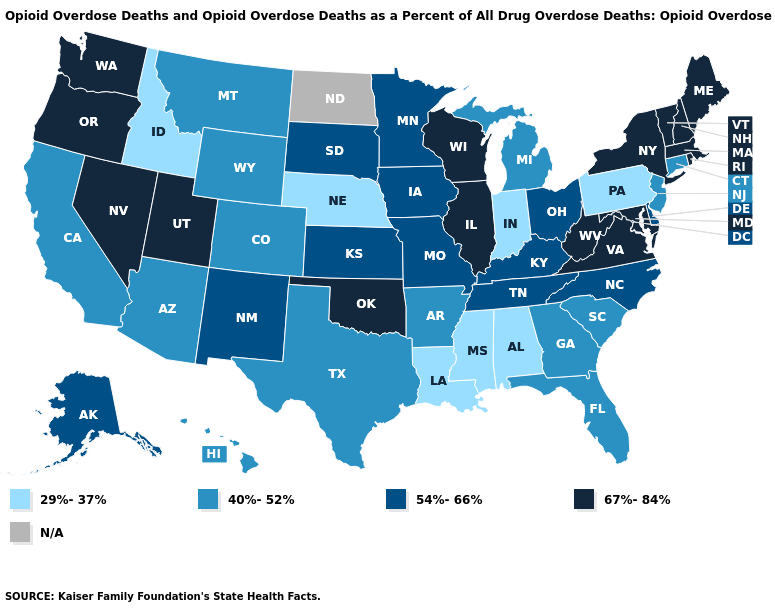How many symbols are there in the legend?
Be succinct. 5. What is the highest value in the Northeast ?
Quick response, please. 67%-84%. What is the highest value in the USA?
Concise answer only. 67%-84%. Is the legend a continuous bar?
Quick response, please. No. What is the value of Colorado?
Answer briefly. 40%-52%. Does the map have missing data?
Keep it brief. Yes. How many symbols are there in the legend?
Answer briefly. 5. What is the value of Maine?
Concise answer only. 67%-84%. Name the states that have a value in the range 40%-52%?
Answer briefly. Arizona, Arkansas, California, Colorado, Connecticut, Florida, Georgia, Hawaii, Michigan, Montana, New Jersey, South Carolina, Texas, Wyoming. What is the value of Tennessee?
Short answer required. 54%-66%. Among the states that border North Dakota , which have the lowest value?
Give a very brief answer. Montana. What is the highest value in the MidWest ?
Be succinct. 67%-84%. Does the map have missing data?
Keep it brief. Yes. What is the value of Michigan?
Be succinct. 40%-52%. 